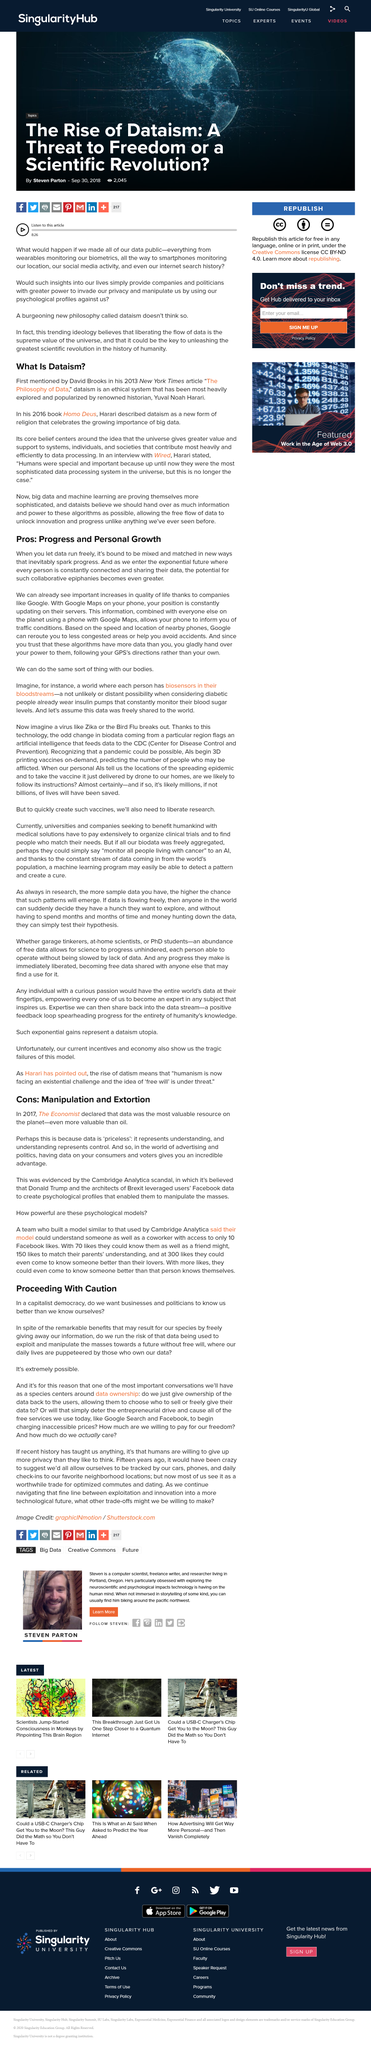Point out several critical features in this image. Google is working towards establishing a constant connection and data sharing among the human race. Dataism, as described by Harari, is a new form of religion that celebrates the growing importance of big data. What brings remarkable benefits to our species is the freely giving away of our information. The concept of dataism was popularized by Yuval Noah Harari. David Brooks was the first to mention the concept of dataism in 2012. 